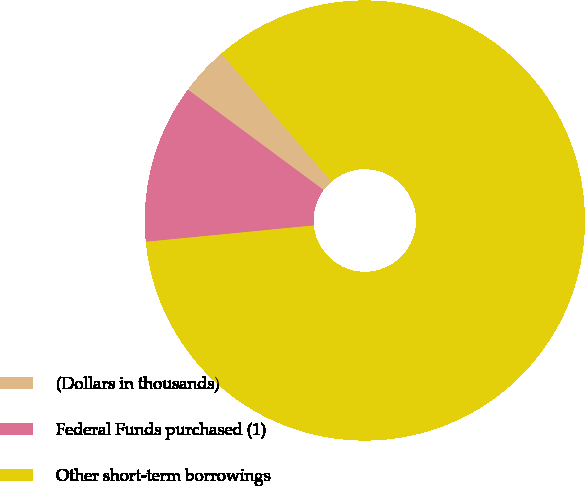Convert chart to OTSL. <chart><loc_0><loc_0><loc_500><loc_500><pie_chart><fcel>(Dollars in thousands)<fcel>Federal Funds purchased (1)<fcel>Other short-term borrowings<nl><fcel>3.57%<fcel>11.68%<fcel>84.75%<nl></chart> 